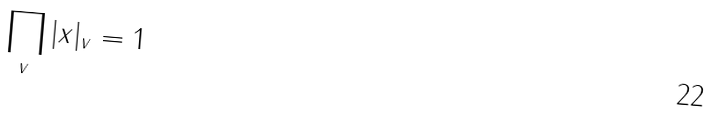<formula> <loc_0><loc_0><loc_500><loc_500>\prod _ { v } | x | _ { v } = 1</formula> 